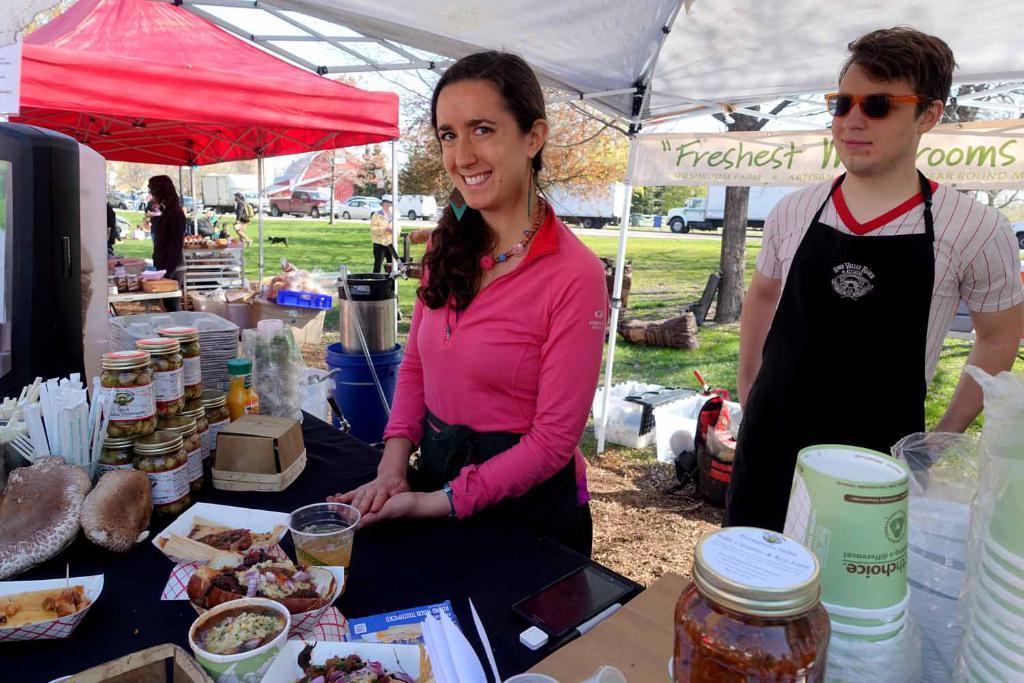Can you describe this image briefly? There are two persons standing on the right side of this image and there are some persons on the left side of this image. There are some tables at the bottom of this image,and there are some food items and some bottles are kept on to this table. There are some trees and cars and come vehicles in the background. There are two tenths as we can see at the top of this image. 